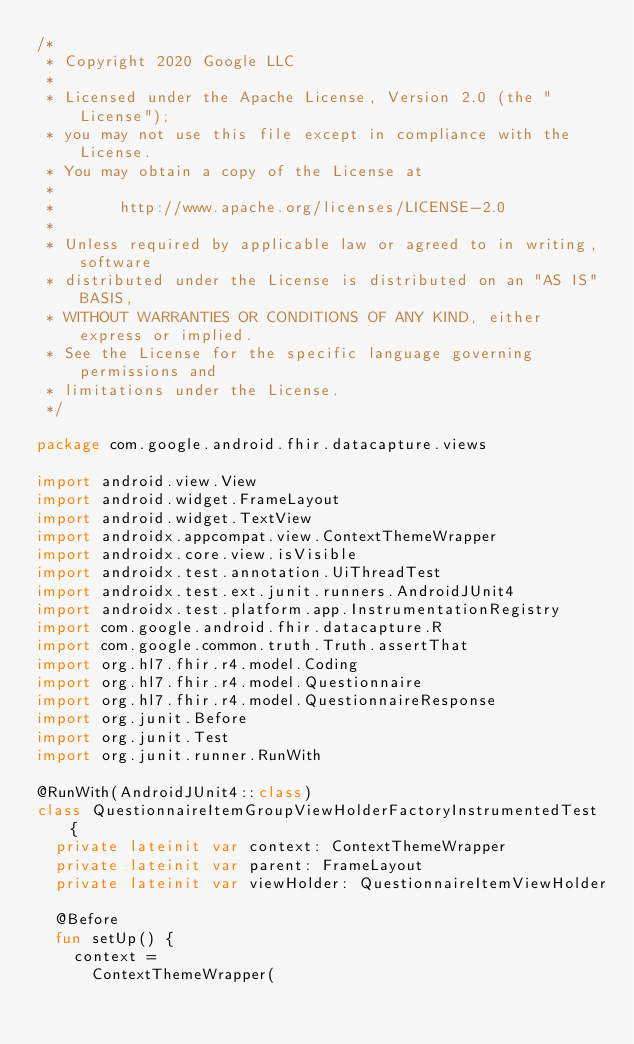Convert code to text. <code><loc_0><loc_0><loc_500><loc_500><_Kotlin_>/*
 * Copyright 2020 Google LLC
 *
 * Licensed under the Apache License, Version 2.0 (the "License");
 * you may not use this file except in compliance with the License.
 * You may obtain a copy of the License at
 *
 *       http://www.apache.org/licenses/LICENSE-2.0
 *
 * Unless required by applicable law or agreed to in writing, software
 * distributed under the License is distributed on an "AS IS" BASIS,
 * WITHOUT WARRANTIES OR CONDITIONS OF ANY KIND, either express or implied.
 * See the License for the specific language governing permissions and
 * limitations under the License.
 */

package com.google.android.fhir.datacapture.views

import android.view.View
import android.widget.FrameLayout
import android.widget.TextView
import androidx.appcompat.view.ContextThemeWrapper
import androidx.core.view.isVisible
import androidx.test.annotation.UiThreadTest
import androidx.test.ext.junit.runners.AndroidJUnit4
import androidx.test.platform.app.InstrumentationRegistry
import com.google.android.fhir.datacapture.R
import com.google.common.truth.Truth.assertThat
import org.hl7.fhir.r4.model.Coding
import org.hl7.fhir.r4.model.Questionnaire
import org.hl7.fhir.r4.model.QuestionnaireResponse
import org.junit.Before
import org.junit.Test
import org.junit.runner.RunWith

@RunWith(AndroidJUnit4::class)
class QuestionnaireItemGroupViewHolderFactoryInstrumentedTest {
  private lateinit var context: ContextThemeWrapper
  private lateinit var parent: FrameLayout
  private lateinit var viewHolder: QuestionnaireItemViewHolder

  @Before
  fun setUp() {
    context =
      ContextThemeWrapper(</code> 